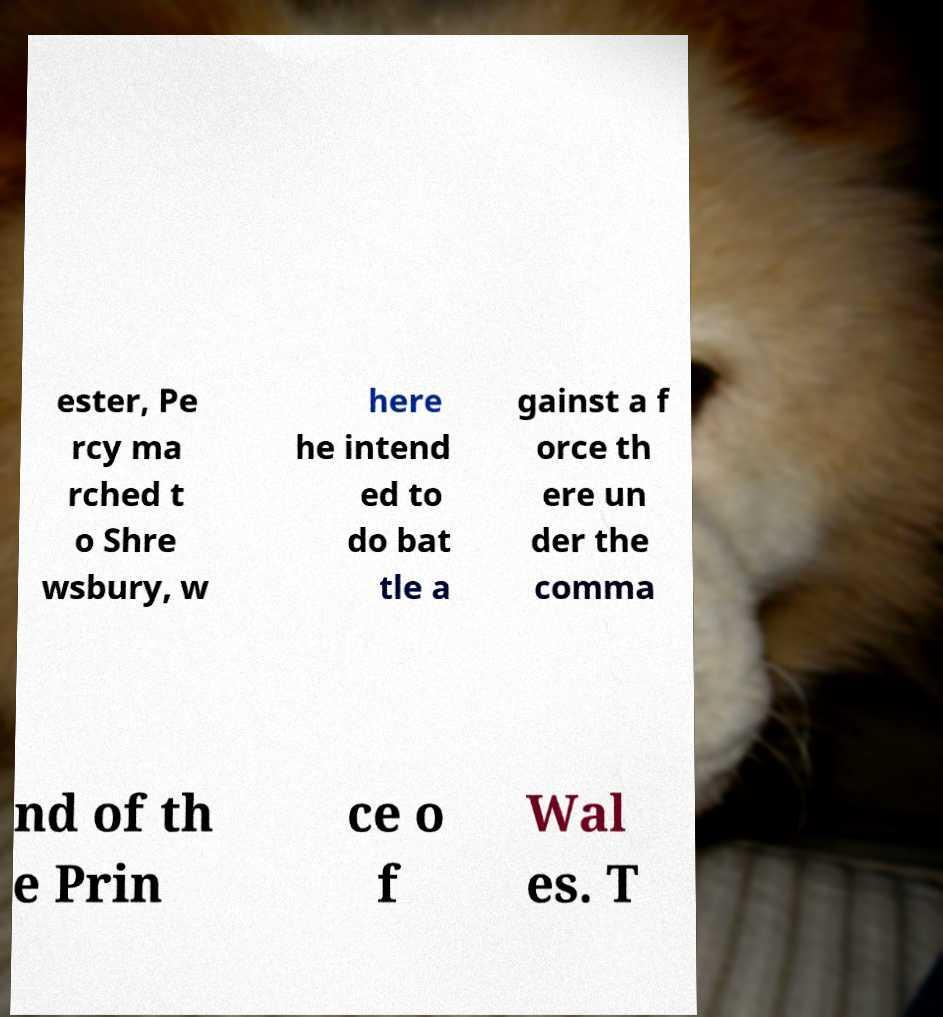Can you accurately transcribe the text from the provided image for me? ester, Pe rcy ma rched t o Shre wsbury, w here he intend ed to do bat tle a gainst a f orce th ere un der the comma nd of th e Prin ce o f Wal es. T 